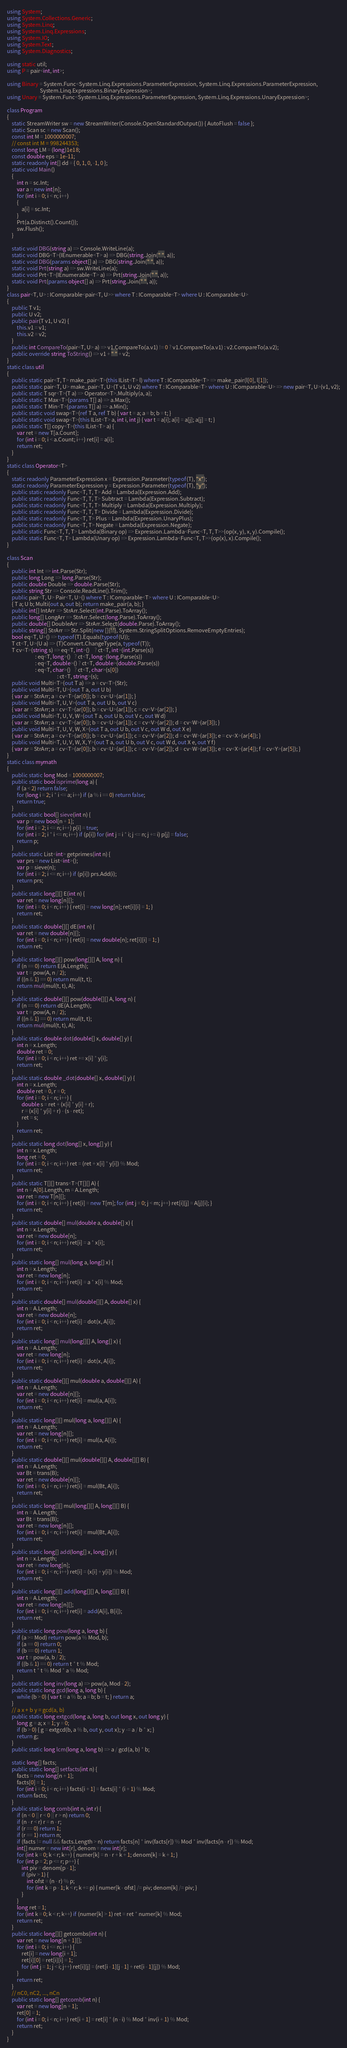Convert code to text. <code><loc_0><loc_0><loc_500><loc_500><_C#_>using System;
using System.Collections.Generic;
using System.Linq;
using System.Linq.Expressions;
using System.IO;
using System.Text;
using System.Diagnostics;

using static util;
using P = pair<int, int>;

using Binary = System.Func<System.Linq.Expressions.ParameterExpression, System.Linq.Expressions.ParameterExpression,
                           System.Linq.Expressions.BinaryExpression>;
using Unary = System.Func<System.Linq.Expressions.ParameterExpression, System.Linq.Expressions.UnaryExpression>;

class Program
{
    static StreamWriter sw = new StreamWriter(Console.OpenStandardOutput()) { AutoFlush = false };
    static Scan sc = new Scan();
    const int M = 1000000007;
    // const int M = 998244353;
    const long LM = (long)1e18;
    const double eps = 1e-11;
    static readonly int[] dd = { 0, 1, 0, -1, 0 };
    static void Main()
    {
        int n = sc.Int;
        var a = new int[n];
        for (int i = 0; i < n; i++)
        {
            a[i] = sc.Int;
        }
        Prt(a.Distinct().Count());
        sw.Flush();
    }

    static void DBG(string a) => Console.WriteLine(a);
    static void DBG<T>(IEnumerable<T> a) => DBG(string.Join(" ", a));
    static void DBG(params object[] a) => DBG(string.Join(" ", a));
    static void Prt(string a) => sw.WriteLine(a);
    static void Prt<T>(IEnumerable<T> a) => Prt(string.Join(" ", a));
    static void Prt(params object[] a) => Prt(string.Join(" ", a));
}
class pair<T, U> : IComparable<pair<T, U>> where T : IComparable<T> where U : IComparable<U>
{
    public T v1;
    public U v2;
    public pair(T v1, U v2) {
        this.v1 = v1;
        this.v2 = v2;
    }
    public int CompareTo(pair<T, U> a) => v1.CompareTo(a.v1) != 0 ? v1.CompareTo(a.v1) : v2.CompareTo(a.v2);
    public override string ToString() => v1 + " " + v2;
}
static class util
{
    public static pair<T, T> make_pair<T>(this IList<T> l) where T : IComparable<T> => make_pair(l[0], l[1]);
    public static pair<T, U> make_pair<T, U>(T v1, U v2) where T : IComparable<T> where U : IComparable<U> => new pair<T, U>(v1, v2);
    public static T sqr<T>(T a) => Operator<T>.Multiply(a, a);
    public static T Max<T>(params T[] a) => a.Max();
    public static T Min<T>(params T[] a) => a.Min();
    public static void swap<T>(ref T a, ref T b) { var t = a; a = b; b = t; }
    public static void swap<T>(this IList<T> a, int i, int j) { var t = a[i]; a[i] = a[j]; a[j] = t; }
    public static T[] copy<T>(this IList<T> a) {
        var ret = new T[a.Count];
        for (int i = 0; i < a.Count; i++) ret[i] = a[i];
        return ret;
    }
}
static class Operator<T>
{
    static readonly ParameterExpression x = Expression.Parameter(typeof(T), "x");
    static readonly ParameterExpression y = Expression.Parameter(typeof(T), "y");
    public static readonly Func<T, T, T> Add = Lambda(Expression.Add);
    public static readonly Func<T, T, T> Subtract = Lambda(Expression.Subtract);
    public static readonly Func<T, T, T> Multiply = Lambda(Expression.Multiply);
    public static readonly Func<T, T, T> Divide = Lambda(Expression.Divide);
    public static readonly Func<T, T> Plus = Lambda(Expression.UnaryPlus);
    public static readonly Func<T, T> Negate = Lambda(Expression.Negate);
    public static Func<T, T, T> Lambda(Binary op) => Expression.Lambda<Func<T, T, T>>(op(x, y), x, y).Compile();
    public static Func<T, T> Lambda(Unary op) => Expression.Lambda<Func<T, T>>(op(x), x).Compile();
}

class Scan
{
    public int Int => int.Parse(Str);
    public long Long => long.Parse(Str);
    public double Double => double.Parse(Str);
    public string Str => Console.ReadLine().Trim();
    public pair<T, U> Pair<T, U>() where T : IComparable<T> where U : IComparable<U>
    { T a; U b; Multi(out a, out b); return make_pair(a, b); }
    public int[] IntArr => StrArr.Select(int.Parse).ToArray();
    public long[] LongArr => StrArr.Select(long.Parse).ToArray();
    public double[] DoubleArr => StrArr.Select(double.Parse).ToArray();
    public string[] StrArr => Str.Split(new []{' '}, System.StringSplitOptions.RemoveEmptyEntries);
    bool eq<T, U>() => typeof(T).Equals(typeof(U));
    T ct<T, U>(U a) => (T)Convert.ChangeType(a, typeof(T));
    T cv<T>(string s) => eq<T, int>()    ? ct<T, int>(int.Parse(s))
                       : eq<T, long>()   ? ct<T, long>(long.Parse(s))
                       : eq<T, double>() ? ct<T, double>(double.Parse(s))
                       : eq<T, char>()   ? ct<T, char>(s[0])
                                         : ct<T, string>(s);
    public void Multi<T>(out T a) => a = cv<T>(Str);
    public void Multi<T, U>(out T a, out U b)
    { var ar = StrArr; a = cv<T>(ar[0]); b = cv<U>(ar[1]); }
    public void Multi<T, U, V>(out T a, out U b, out V c)
    { var ar = StrArr; a = cv<T>(ar[0]); b = cv<U>(ar[1]); c = cv<V>(ar[2]); }
    public void Multi<T, U, V, W>(out T a, out U b, out V c, out W d)
    { var ar = StrArr; a = cv<T>(ar[0]); b = cv<U>(ar[1]); c = cv<V>(ar[2]); d = cv<W>(ar[3]); }
    public void Multi<T, U, V, W, X>(out T a, out U b, out V c, out W d, out X e)
    { var ar = StrArr; a = cv<T>(ar[0]); b = cv<U>(ar[1]); c = cv<V>(ar[2]); d = cv<W>(ar[3]); e = cv<X>(ar[4]); }
    public void Multi<T, U, V, W, X, Y>(out T a, out U b, out V c, out W d, out X e, out Y f)
    { var ar = StrArr; a = cv<T>(ar[0]); b = cv<U>(ar[1]); c = cv<V>(ar[2]); d = cv<W>(ar[3]); e = cv<X>(ar[4]); f = cv<Y>(ar[5]); }
}
static class mymath
{
    public static long Mod = 1000000007;
    public static bool isprime(long a) {
        if (a < 2) return false;
        for (long i = 2; i * i <= a; i++) if (a % i == 0) return false;
        return true;
    }
    public static bool[] sieve(int n) {
        var p = new bool[n + 1];
        for (int i = 2; i <= n; i++) p[i] = true;
        for (int i = 2; i * i <= n; i++) if (p[i]) for (int j = i * i; j <= n; j += i) p[j] = false;
        return p;
    }
    public static List<int> getprimes(int n) {
        var prs = new List<int>();
        var p = sieve(n);
        for (int i = 2; i <= n; i++) if (p[i]) prs.Add(i);
        return prs;
    }
    public static long[][] E(int n) {
        var ret = new long[n][];
        for (int i = 0; i < n; i++) { ret[i] = new long[n]; ret[i][i] = 1; }
        return ret;
    }
    public static double[][] dE(int n) {
        var ret = new double[n][];
        for (int i = 0; i < n; i++) { ret[i] = new double[n]; ret[i][i] = 1; }
        return ret;
    }
    public static long[][] pow(long[][] A, long n) {
        if (n == 0) return E(A.Length);
        var t = pow(A, n / 2);
        if ((n & 1) == 0) return mul(t, t);
        return mul(mul(t, t), A);
    }
    public static double[][] pow(double[][] A, long n) {
        if (n == 0) return dE(A.Length);
        var t = pow(A, n / 2);
        if ((n & 1) == 0) return mul(t, t);
        return mul(mul(t, t), A);
    }
    public static double dot(double[] x, double[] y) {
        int n = x.Length;
        double ret = 0;
        for (int i = 0; i < n; i++) ret += x[i] * y[i];
        return ret;
    }
    public static double _dot(double[] x, double[] y) {
        int n = x.Length;
        double ret = 0, r = 0;
        for (int i = 0; i < n; i++) {
            double s = ret + (x[i] * y[i] + r);
            r = (x[i] * y[i] + r) - (s - ret);
            ret = s;
        }
        return ret;
    }
    public static long dot(long[] x, long[] y) {
        int n = x.Length;
        long ret = 0;
        for (int i = 0; i < n; i++) ret = (ret + x[i] * y[i]) % Mod;
        return ret;
    }
    public static T[][] trans<T>(T[][] A) {
        int n = A[0].Length, m = A.Length;
        var ret = new T[n][];
        for (int i = 0; i < n; i++) { ret[i] = new T[m]; for (int j = 0; j < m; j++) ret[i][j] = A[j][i]; }
        return ret;
    }
    public static double[] mul(double a, double[] x) {
        int n = x.Length;
        var ret = new double[n];
        for (int i = 0; i < n; i++) ret[i] = a * x[i];
        return ret;
    }
    public static long[] mul(long a, long[] x) {
        int n = x.Length;
        var ret = new long[n];
        for (int i = 0; i < n; i++) ret[i] = a * x[i] % Mod;
        return ret;
    }
    public static double[] mul(double[][] A, double[] x) {
        int n = A.Length;
        var ret = new double[n];
        for (int i = 0; i < n; i++) ret[i] = dot(x, A[i]);
        return ret;
    }
    public static long[] mul(long[][] A, long[] x) {
        int n = A.Length;
        var ret = new long[n];
        for (int i = 0; i < n; i++) ret[i] = dot(x, A[i]);
        return ret;
    }
    public static double[][] mul(double a, double[][] A) {
        int n = A.Length;
        var ret = new double[n][];
        for (int i = 0; i < n; i++) ret[i] = mul(a, A[i]);
        return ret;
    }
    public static long[][] mul(long a, long[][] A) {
        int n = A.Length;
        var ret = new long[n][];
        for (int i = 0; i < n; i++) ret[i] = mul(a, A[i]);
        return ret;
    }
    public static double[][] mul(double[][] A, double[][] B) {
        int n = A.Length;
        var Bt = trans(B);
        var ret = new double[n][];
        for (int i = 0; i < n; i++) ret[i] = mul(Bt, A[i]);
        return ret;
    }
    public static long[][] mul(long[][] A, long[][] B) {
        int n = A.Length;
        var Bt = trans(B);
        var ret = new long[n][];
        for (int i = 0; i < n; i++) ret[i] = mul(Bt, A[i]);
        return ret;
    }
    public static long[] add(long[] x, long[] y) {
        int n = x.Length;
        var ret = new long[n];
        for (int i = 0; i < n; i++) ret[i] = (x[i] + y[i]) % Mod;
        return ret;
    }
    public static long[][] add(long[][] A, long[][] B) {
        int n = A.Length;
        var ret = new long[n][];
        for (int i = 0; i < n; i++) ret[i] = add(A[i], B[i]);
        return ret;
    }
    public static long pow(long a, long b) {
        if (a >= Mod) return pow(a % Mod, b);
        if (a == 0) return 0;
        if (b == 0) return 1;
        var t = pow(a, b / 2);
        if ((b & 1) == 0) return t * t % Mod;
        return t * t % Mod * a % Mod;
    }
    public static long inv(long a) => pow(a, Mod - 2);
    public static long gcd(long a, long b) {
        while (b > 0) { var t = a % b; a = b; b = t; } return a;
    }
    // a x + b y = gcd(a, b)
    public static long extgcd(long a, long b, out long x, out long y) {
        long g = a; x = 1; y = 0;
        if (b > 0) { g = extgcd(b, a % b, out y, out x); y -= a / b * x; }
        return g;
    }
    public static long lcm(long a, long b) => a / gcd(a, b) * b;

    static long[] facts;
    public static long[] setfacts(int n) {
        facts = new long[n + 1];
        facts[0] = 1;
        for (int i = 0; i < n; i++) facts[i + 1] = facts[i] * (i + 1) % Mod;
        return facts;
    }
    public static long comb(int n, int r) {
        if (n < 0 || r < 0 || r > n) return 0;
        if (n - r < r) r = n - r;
        if (r == 0) return 1;
        if (r == 1) return n;
        if (facts != null && facts.Length > n) return facts[n] * inv(facts[r]) % Mod * inv(facts[n - r]) % Mod;
        int[] numer = new int[r], denom = new int[r];
        for (int k = 0; k < r; k++) { numer[k] = n - r + k + 1; denom[k] = k + 1; }
        for (int p = 2; p <= r; p++) {
            int piv = denom[p - 1];
            if (piv > 1) {
                int ofst = (n - r) % p;
                for (int k = p - 1; k < r; k += p) { numer[k - ofst] /= piv; denom[k] /= piv; }
            }
        }
        long ret = 1;
        for (int k = 0; k < r; k++) if (numer[k] > 1) ret = ret * numer[k] % Mod;
        return ret;
    }
    public static long[][] getcombs(int n) {
        var ret = new long[n + 1][];
        for (int i = 0; i <= n; i++) {
            ret[i] = new long[i + 1];
            ret[i][0] = ret[i][i] = 1;
            for (int j = 1; j < i; j++) ret[i][j] = (ret[i - 1][j - 1] + ret[i - 1][j]) % Mod;
        }
        return ret;
    }
    // nC0, nC2, ..., nCn
    public static long[] getcomb(int n) {
        var ret = new long[n + 1];
        ret[0] = 1;
        for (int i = 0; i < n; i++) ret[i + 1] = ret[i] * (n - i) % Mod * inv(i + 1) % Mod;
        return ret;
    }
}
</code> 